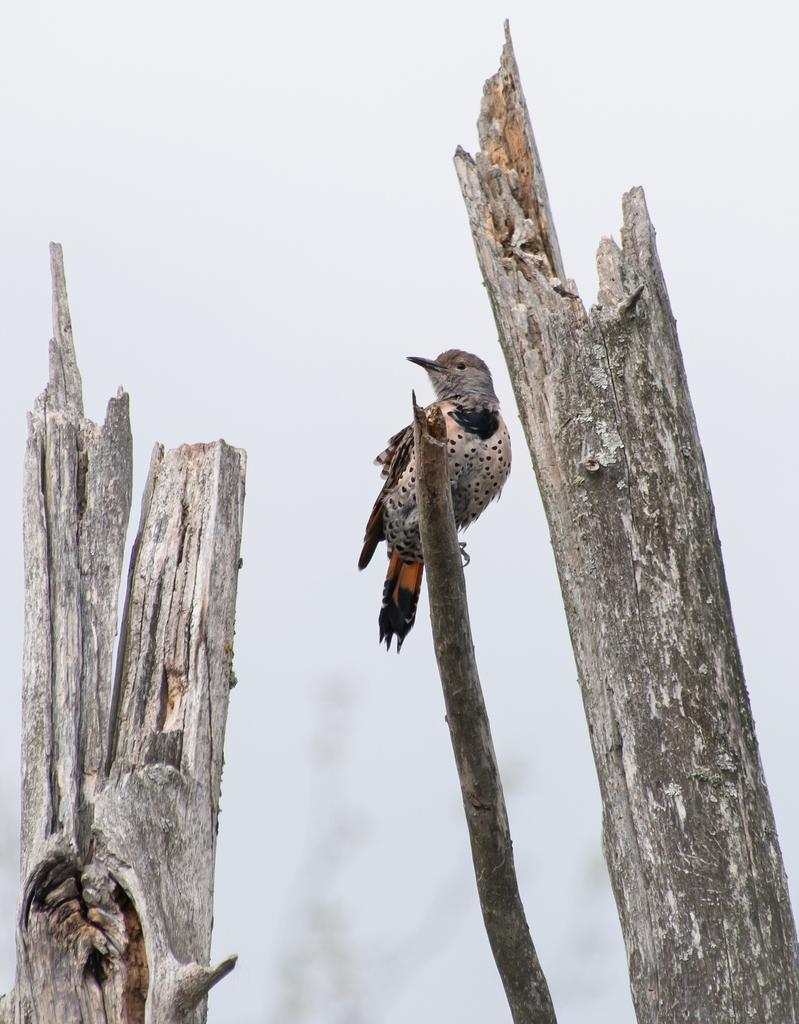What type of animal can be seen in the image? There is a bird in the image. What is the bird perched on? The bird is on a wooden stick. Are there any other wooden sticks visible in the image? Yes, there are wooden sticks on either side of the bird. What can be seen in the background of the image? The sky is visible in the background of the image. What degree does the crook have in the image? There is no crook present in the image, and therefore no degree can be associated with it. What type of wood is used for the sticks in the image? The provided facts do not specify the type of wood used for the sticks in the image. 